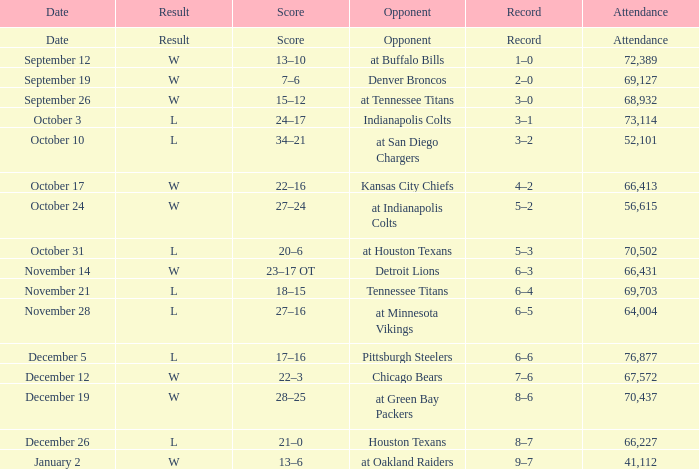What score does houston texans have as the adversary? 21–0. 